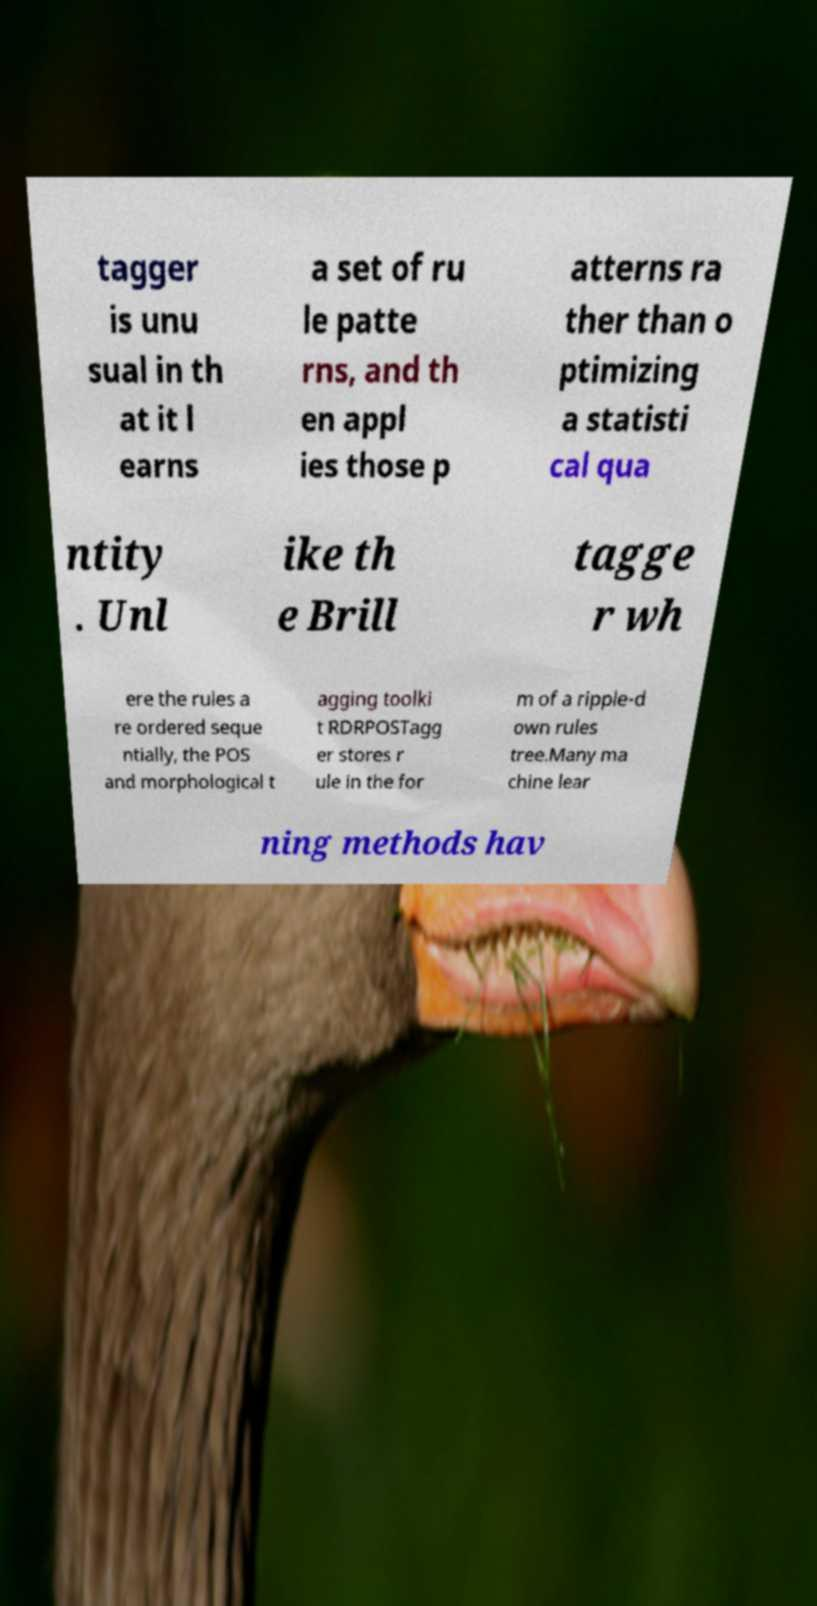Please read and relay the text visible in this image. What does it say? tagger is unu sual in th at it l earns a set of ru le patte rns, and th en appl ies those p atterns ra ther than o ptimizing a statisti cal qua ntity . Unl ike th e Brill tagge r wh ere the rules a re ordered seque ntially, the POS and morphological t agging toolki t RDRPOSTagg er stores r ule in the for m of a ripple-d own rules tree.Many ma chine lear ning methods hav 